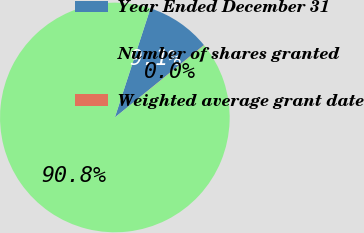Convert chart. <chart><loc_0><loc_0><loc_500><loc_500><pie_chart><fcel>Year Ended December 31<fcel>Number of shares granted<fcel>Weighted average grant date<nl><fcel>9.12%<fcel>90.85%<fcel>0.04%<nl></chart> 